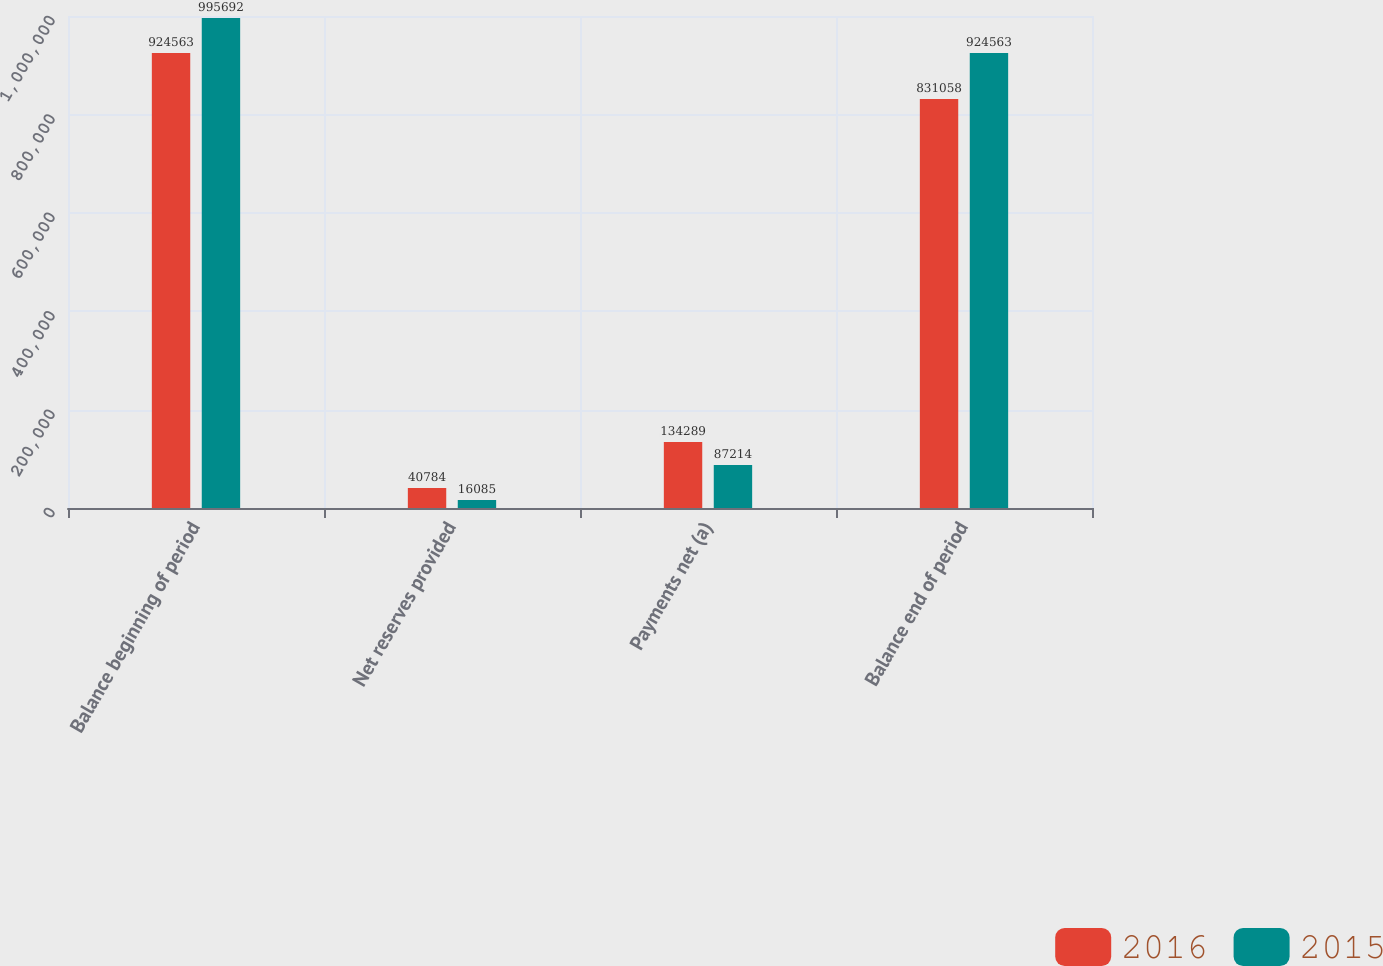Convert chart. <chart><loc_0><loc_0><loc_500><loc_500><stacked_bar_chart><ecel><fcel>Balance beginning of period<fcel>Net reserves provided<fcel>Payments net (a)<fcel>Balance end of period<nl><fcel>2016<fcel>924563<fcel>40784<fcel>134289<fcel>831058<nl><fcel>2015<fcel>995692<fcel>16085<fcel>87214<fcel>924563<nl></chart> 